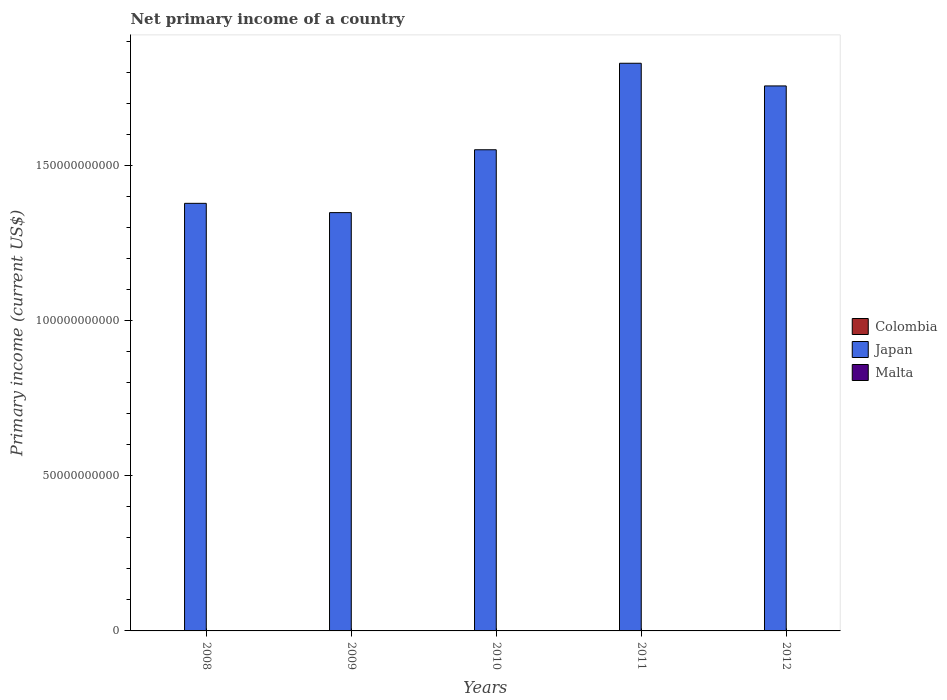How many bars are there on the 2nd tick from the left?
Your answer should be very brief. 1. In how many cases, is the number of bars for a given year not equal to the number of legend labels?
Keep it short and to the point. 5. What is the primary income in Malta in 2012?
Your answer should be compact. 0. Across all years, what is the maximum primary income in Japan?
Your response must be concise. 1.83e+11. Across all years, what is the minimum primary income in Colombia?
Your answer should be compact. 0. What is the total primary income in Japan in the graph?
Your answer should be very brief. 7.86e+11. What is the difference between the primary income in Japan in 2010 and that in 2012?
Your response must be concise. -2.06e+1. What is the difference between the primary income in Malta in 2010 and the primary income in Japan in 2012?
Your answer should be very brief. -1.76e+11. What is the average primary income in Japan per year?
Provide a short and direct response. 1.57e+11. What is the ratio of the primary income in Japan in 2009 to that in 2011?
Offer a terse response. 0.74. What is the difference between the highest and the second highest primary income in Japan?
Make the answer very short. 7.31e+09. What is the difference between the highest and the lowest primary income in Japan?
Offer a very short reply. 4.81e+1. Is the sum of the primary income in Japan in 2008 and 2009 greater than the maximum primary income in Malta across all years?
Your answer should be very brief. Yes. How many bars are there?
Your response must be concise. 5. Are all the bars in the graph horizontal?
Offer a terse response. No. How many years are there in the graph?
Ensure brevity in your answer.  5. What is the difference between two consecutive major ticks on the Y-axis?
Your response must be concise. 5.00e+1. Are the values on the major ticks of Y-axis written in scientific E-notation?
Provide a short and direct response. No. Does the graph contain grids?
Provide a succinct answer. No. Where does the legend appear in the graph?
Your answer should be compact. Center right. How are the legend labels stacked?
Provide a succinct answer. Vertical. What is the title of the graph?
Keep it short and to the point. Net primary income of a country. Does "Brunei Darussalam" appear as one of the legend labels in the graph?
Provide a short and direct response. No. What is the label or title of the Y-axis?
Offer a very short reply. Primary income (current US$). What is the Primary income (current US$) in Colombia in 2008?
Your answer should be very brief. 0. What is the Primary income (current US$) of Japan in 2008?
Keep it short and to the point. 1.38e+11. What is the Primary income (current US$) in Malta in 2008?
Your response must be concise. 0. What is the Primary income (current US$) in Japan in 2009?
Offer a terse response. 1.35e+11. What is the Primary income (current US$) in Malta in 2009?
Give a very brief answer. 0. What is the Primary income (current US$) of Colombia in 2010?
Provide a succinct answer. 0. What is the Primary income (current US$) in Japan in 2010?
Your response must be concise. 1.55e+11. What is the Primary income (current US$) of Malta in 2010?
Your answer should be very brief. 0. What is the Primary income (current US$) in Colombia in 2011?
Provide a succinct answer. 0. What is the Primary income (current US$) in Japan in 2011?
Your answer should be very brief. 1.83e+11. What is the Primary income (current US$) in Colombia in 2012?
Your response must be concise. 0. What is the Primary income (current US$) of Japan in 2012?
Ensure brevity in your answer.  1.76e+11. Across all years, what is the maximum Primary income (current US$) of Japan?
Offer a very short reply. 1.83e+11. Across all years, what is the minimum Primary income (current US$) of Japan?
Provide a succinct answer. 1.35e+11. What is the total Primary income (current US$) in Colombia in the graph?
Your answer should be very brief. 0. What is the total Primary income (current US$) in Japan in the graph?
Your answer should be compact. 7.86e+11. What is the difference between the Primary income (current US$) in Japan in 2008 and that in 2009?
Give a very brief answer. 3.00e+09. What is the difference between the Primary income (current US$) in Japan in 2008 and that in 2010?
Your answer should be very brief. -1.73e+1. What is the difference between the Primary income (current US$) in Japan in 2008 and that in 2011?
Offer a very short reply. -4.51e+1. What is the difference between the Primary income (current US$) in Japan in 2008 and that in 2012?
Your answer should be very brief. -3.78e+1. What is the difference between the Primary income (current US$) in Japan in 2009 and that in 2010?
Provide a succinct answer. -2.03e+1. What is the difference between the Primary income (current US$) in Japan in 2009 and that in 2011?
Ensure brevity in your answer.  -4.81e+1. What is the difference between the Primary income (current US$) of Japan in 2009 and that in 2012?
Offer a very short reply. -4.08e+1. What is the difference between the Primary income (current US$) in Japan in 2010 and that in 2011?
Your answer should be very brief. -2.79e+1. What is the difference between the Primary income (current US$) in Japan in 2010 and that in 2012?
Give a very brief answer. -2.06e+1. What is the difference between the Primary income (current US$) in Japan in 2011 and that in 2012?
Provide a succinct answer. 7.31e+09. What is the average Primary income (current US$) of Japan per year?
Your response must be concise. 1.57e+11. What is the ratio of the Primary income (current US$) of Japan in 2008 to that in 2009?
Offer a very short reply. 1.02. What is the ratio of the Primary income (current US$) in Japan in 2008 to that in 2010?
Keep it short and to the point. 0.89. What is the ratio of the Primary income (current US$) in Japan in 2008 to that in 2011?
Offer a very short reply. 0.75. What is the ratio of the Primary income (current US$) of Japan in 2008 to that in 2012?
Make the answer very short. 0.78. What is the ratio of the Primary income (current US$) in Japan in 2009 to that in 2010?
Give a very brief answer. 0.87. What is the ratio of the Primary income (current US$) of Japan in 2009 to that in 2011?
Make the answer very short. 0.74. What is the ratio of the Primary income (current US$) in Japan in 2009 to that in 2012?
Make the answer very short. 0.77. What is the ratio of the Primary income (current US$) in Japan in 2010 to that in 2011?
Provide a short and direct response. 0.85. What is the ratio of the Primary income (current US$) of Japan in 2010 to that in 2012?
Your answer should be compact. 0.88. What is the ratio of the Primary income (current US$) of Japan in 2011 to that in 2012?
Your answer should be very brief. 1.04. What is the difference between the highest and the second highest Primary income (current US$) of Japan?
Your answer should be very brief. 7.31e+09. What is the difference between the highest and the lowest Primary income (current US$) in Japan?
Offer a terse response. 4.81e+1. 